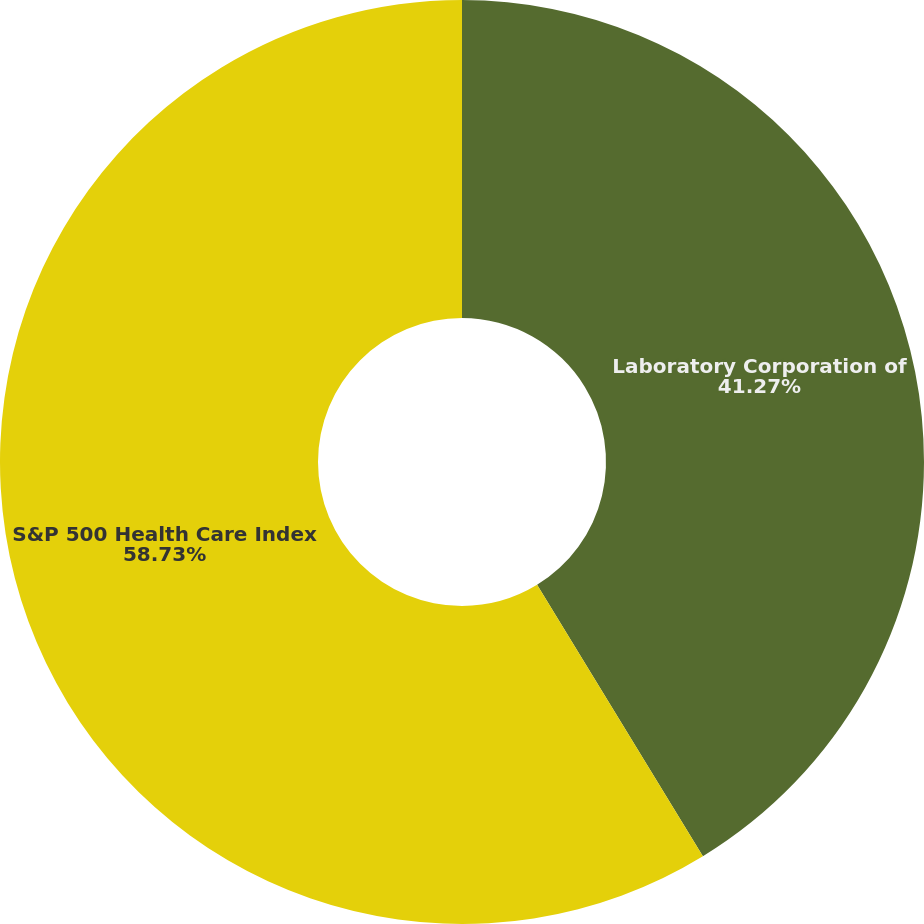Convert chart to OTSL. <chart><loc_0><loc_0><loc_500><loc_500><pie_chart><fcel>Laboratory Corporation of<fcel>S&P 500 Health Care Index<nl><fcel>41.27%<fcel>58.73%<nl></chart> 